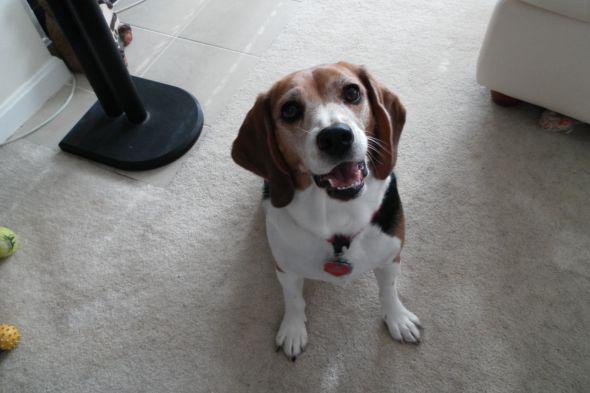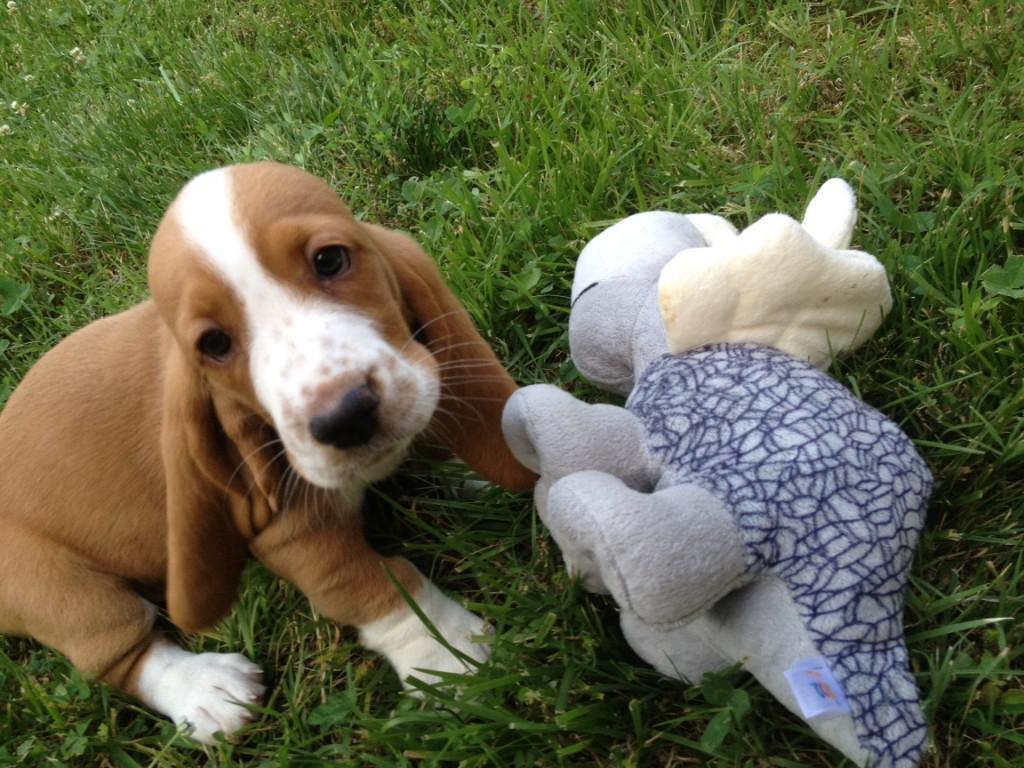The first image is the image on the left, the second image is the image on the right. Analyze the images presented: Is the assertion "There is an image of a tan and white puppy sitting on grass." valid? Answer yes or no. Yes. The first image is the image on the left, the second image is the image on the right. Examine the images to the left and right. Is the description "the right image has a puppy on a grassy surface" accurate? Answer yes or no. Yes. 